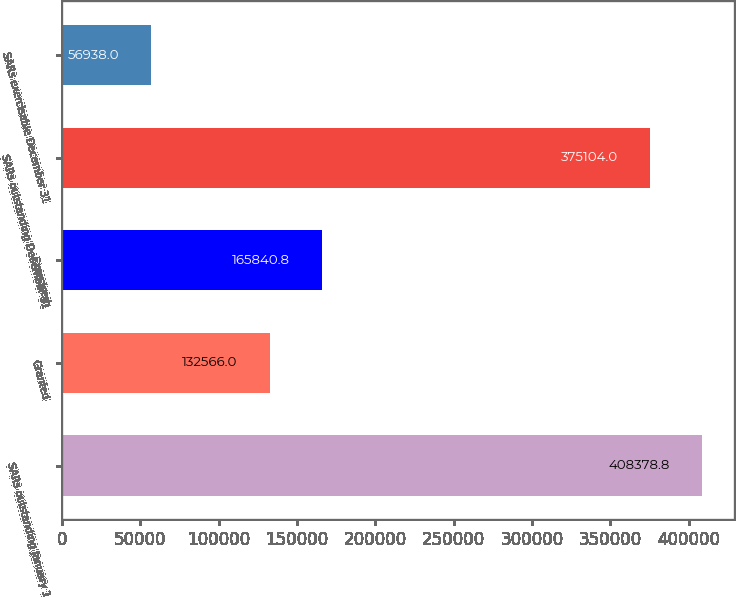Convert chart to OTSL. <chart><loc_0><loc_0><loc_500><loc_500><bar_chart><fcel>SARs outstanding January 1<fcel>Granted<fcel>Exercised<fcel>SARs outstanding December 31<fcel>SARs exercisable December 31<nl><fcel>408379<fcel>132566<fcel>165841<fcel>375104<fcel>56938<nl></chart> 